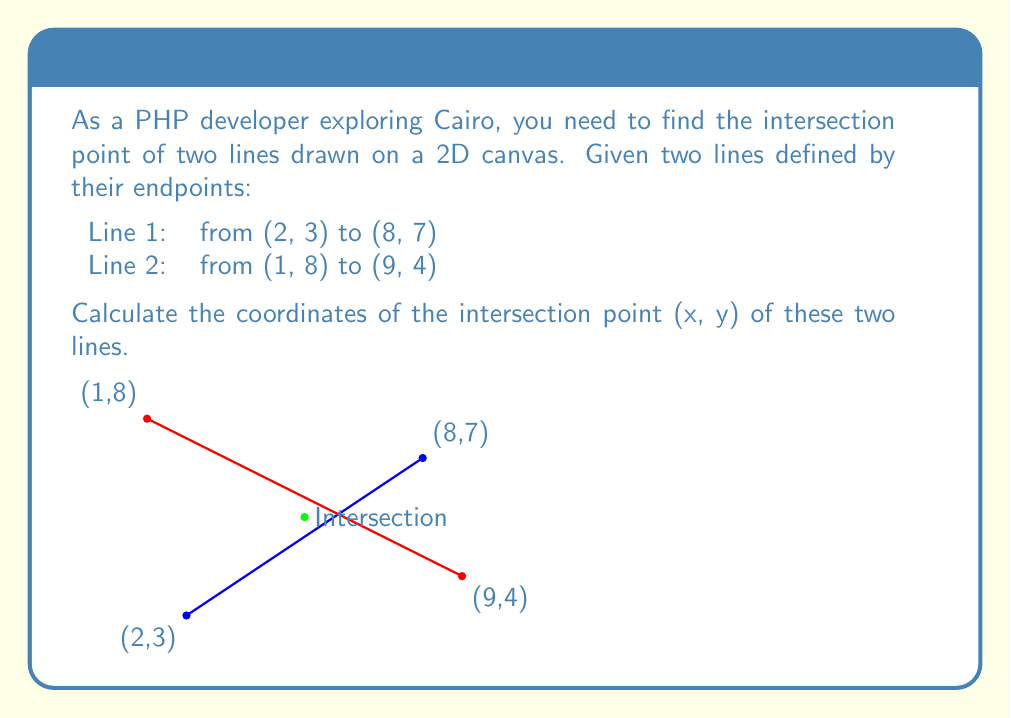Could you help me with this problem? To solve this problem, we'll use the following steps:

1) First, we need to find the equations of both lines in the form $y = mx + b$, where $m$ is the slope and $b$ is the y-intercept.

2) For Line 1:
   Slope $m_1 = \frac{y_2 - y_1}{x_2 - x_1} = \frac{7 - 3}{8 - 2} = \frac{4}{6} = \frac{2}{3}$
   Using point (2, 3): $3 = \frac{2}{3}(2) + b_1$
   Solving for $b_1$: $b_1 = 3 - \frac{4}{3} = \frac{5}{3}$
   Equation of Line 1: $y = \frac{2}{3}x + \frac{5}{3}$

3) For Line 2:
   Slope $m_2 = \frac{y_2 - y_1}{x_2 - x_1} = \frac{4 - 8}{9 - 1} = -\frac{1}{2}$
   Using point (1, 8): $8 = -\frac{1}{2}(1) + b_2$
   Solving for $b_2$: $b_2 = 8 + \frac{1}{2} = \frac{17}{2}$
   Equation of Line 2: $y = -\frac{1}{2}x + \frac{17}{2}$

4) At the intersection point, the x and y coordinates will be the same for both lines. So we can set the equations equal to each other:

   $\frac{2}{3}x + \frac{5}{3} = -\frac{1}{2}x + \frac{17}{2}$

5) Solve for x:
   $\frac{2}{3}x + \frac{1}{2}x = \frac{17}{2} - \frac{5}{3}$
   $\frac{4}{6}x + \frac{3}{6}x = \frac{51}{6} - \frac{10}{6}$
   $\frac{7}{6}x = \frac{41}{6}$
   $x = \frac{41}{6} \div \frac{7}{6} = \frac{41}{7}$

6) Substitute this x value into either line equation to find y:
   $y = \frac{2}{3}(\frac{41}{7}) + \frac{5}{3} = \frac{82}{21} + \frac{35}{21} = \frac{117}{21}$

Therefore, the intersection point is $(\frac{41}{7}, \frac{117}{21})$ or approximately (5.86, 5.57).
Answer: The intersection point of the two lines is $(\frac{41}{7}, \frac{117}{21})$ or approximately (5.86, 5.57). 